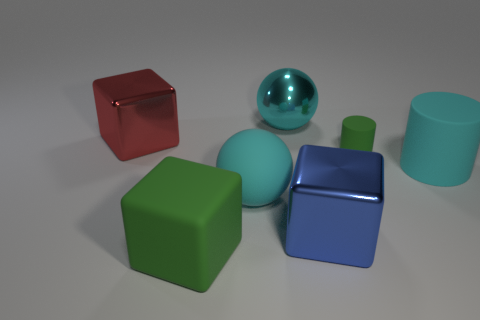Subtract all big shiny blocks. How many blocks are left? 1 Add 3 large spheres. How many objects exist? 10 Add 6 cyan spheres. How many cyan spheres are left? 8 Add 3 gray blocks. How many gray blocks exist? 3 Subtract 0 gray balls. How many objects are left? 7 Subtract all balls. How many objects are left? 5 Subtract all green matte cylinders. Subtract all spheres. How many objects are left? 4 